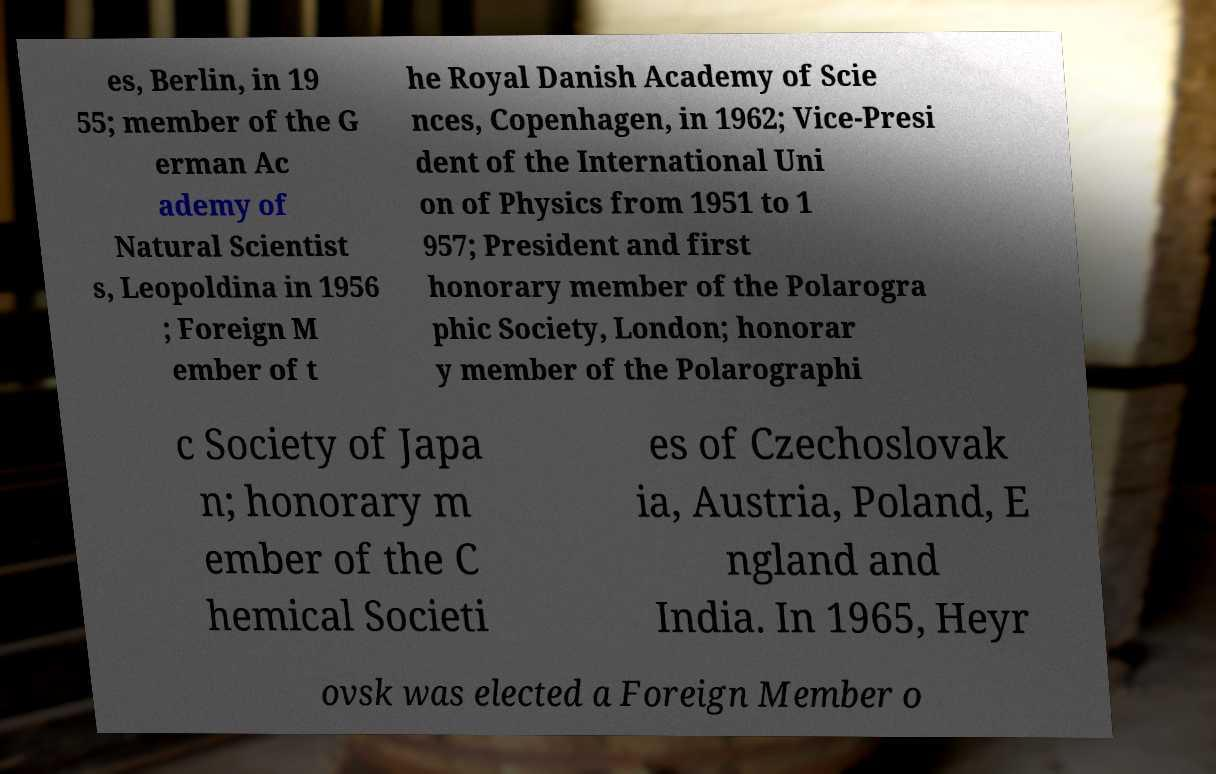Could you assist in decoding the text presented in this image and type it out clearly? es, Berlin, in 19 55; member of the G erman Ac ademy of Natural Scientist s, Leopoldina in 1956 ; Foreign M ember of t he Royal Danish Academy of Scie nces, Copenhagen, in 1962; Vice-Presi dent of the International Uni on of Physics from 1951 to 1 957; President and first honorary member of the Polarogra phic Society, London; honorar y member of the Polarographi c Society of Japa n; honorary m ember of the C hemical Societi es of Czechoslovak ia, Austria, Poland, E ngland and India. In 1965, Heyr ovsk was elected a Foreign Member o 